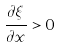Convert formula to latex. <formula><loc_0><loc_0><loc_500><loc_500>\frac { \partial \xi } { \partial x } > 0</formula> 